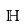<formula> <loc_0><loc_0><loc_500><loc_500>\mathbb { H }</formula> 